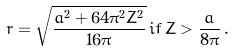<formula> <loc_0><loc_0><loc_500><loc_500>r = \sqrt { \frac { a ^ { 2 } + 6 4 \pi ^ { 2 } Z ^ { 2 } } { 1 6 \pi } } \, i f \, Z > \frac { a } { 8 \pi } \, .</formula> 